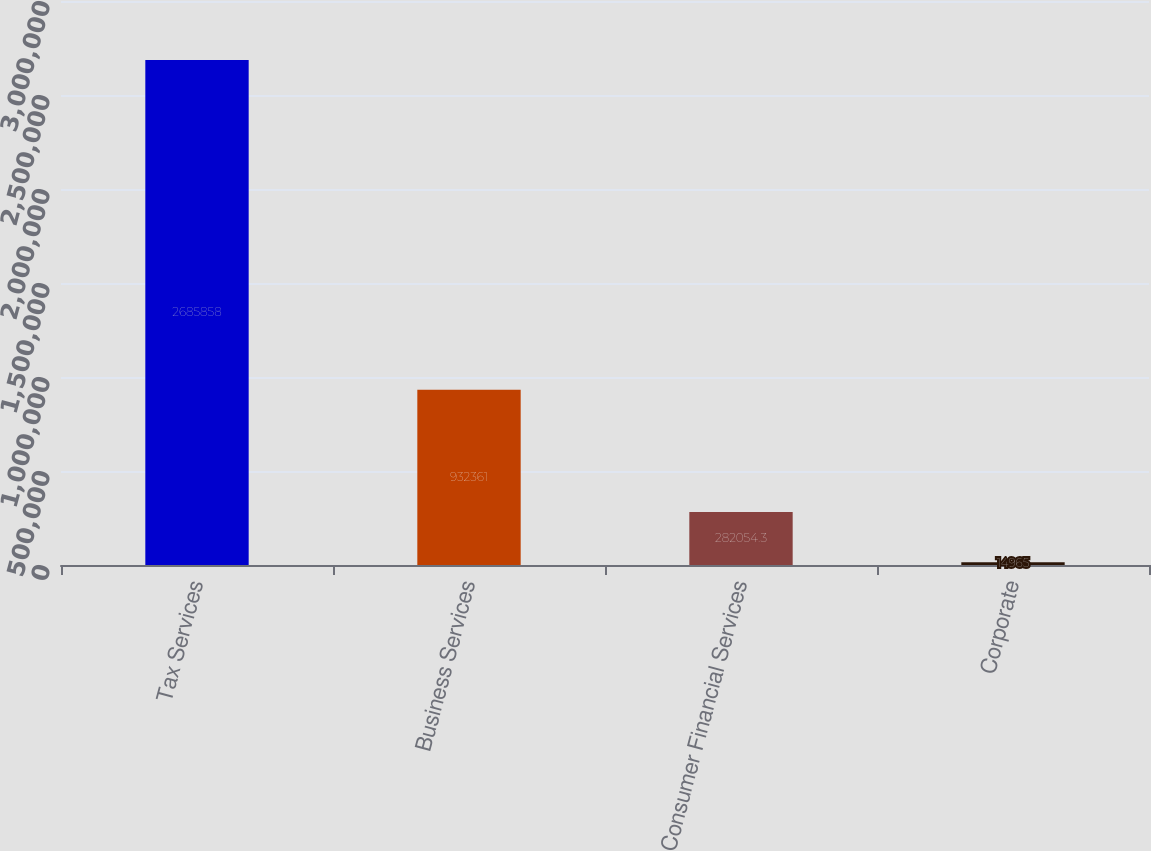<chart> <loc_0><loc_0><loc_500><loc_500><bar_chart><fcel>Tax Services<fcel>Business Services<fcel>Consumer Financial Services<fcel>Corporate<nl><fcel>2.68586e+06<fcel>932361<fcel>282054<fcel>14965<nl></chart> 